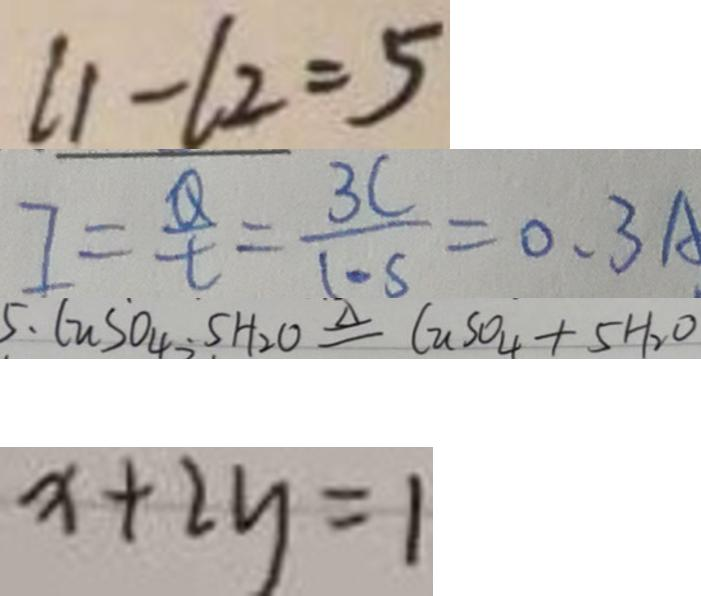Convert formula to latex. <formula><loc_0><loc_0><loc_500><loc_500>l 1 - l 2 = 5 
 I = \frac { Q } { t } = \frac { 3 C } { 1 \cdots } = 0 . 3 A . 
 5 . C u S O _ { 4 } . 5 H _ { 2 } O \xlongequal { \Delta } C u S O _ { 4 } + 5 H _ { 2 } O 
 x + 2 y = 1</formula> 